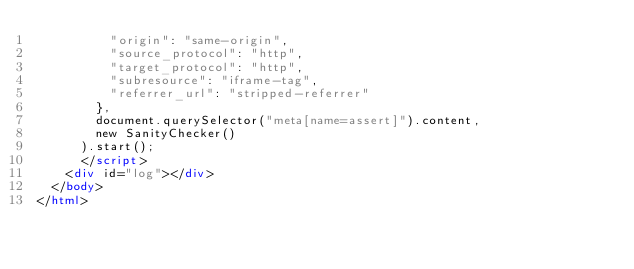<code> <loc_0><loc_0><loc_500><loc_500><_HTML_>          "origin": "same-origin",
          "source_protocol": "http",
          "target_protocol": "http",
          "subresource": "iframe-tag",
          "referrer_url": "stripped-referrer"
        },
        document.querySelector("meta[name=assert]").content,
        new SanityChecker()
      ).start();
      </script>
    <div id="log"></div>
  </body>
</html>
</code> 